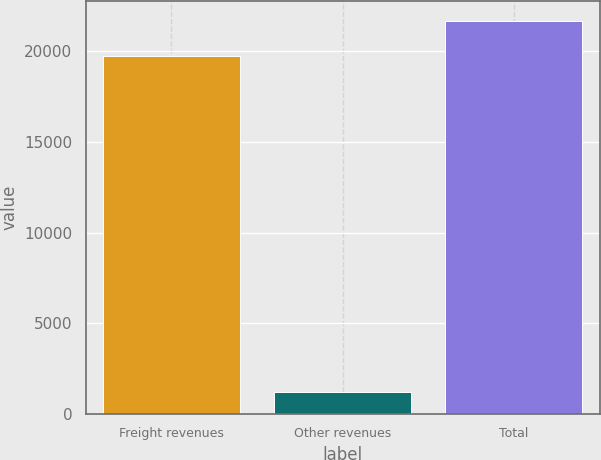<chart> <loc_0><loc_0><loc_500><loc_500><bar_chart><fcel>Freight revenues<fcel>Other revenues<fcel>Total<nl><fcel>19686<fcel>1240<fcel>21654.6<nl></chart> 